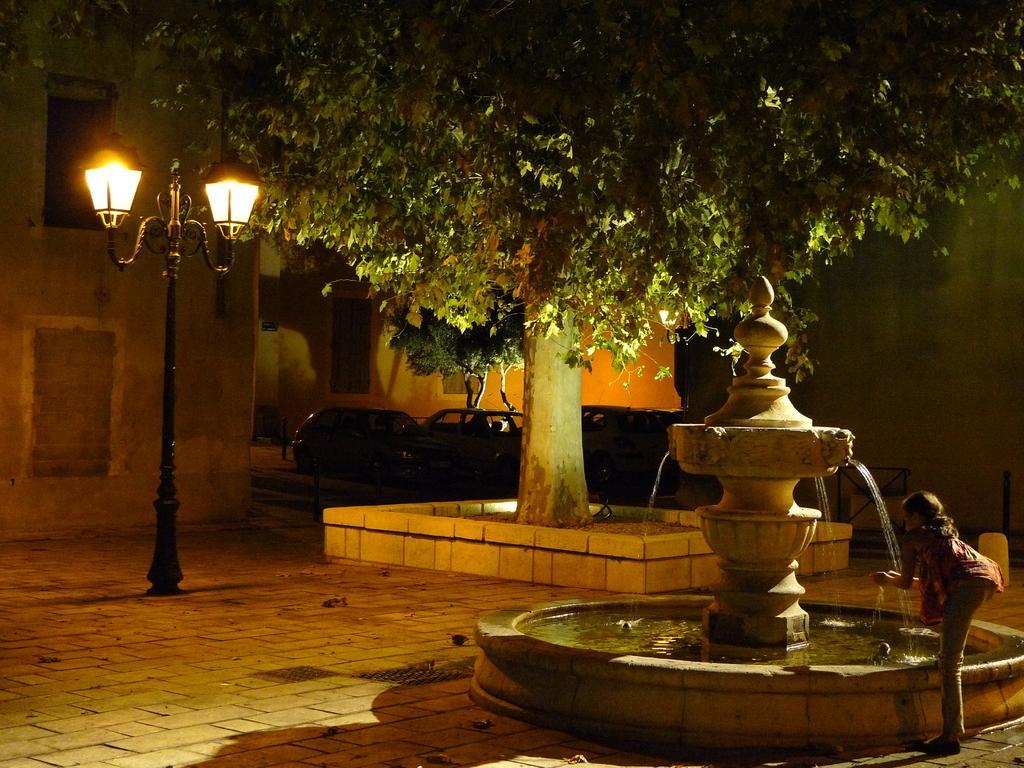Please provide a concise description of this image. In the picture I can see a person standing near the water fountain. Here I can see the trees, light poles, vehicles parked on the road and I can see the buildings in the background. 